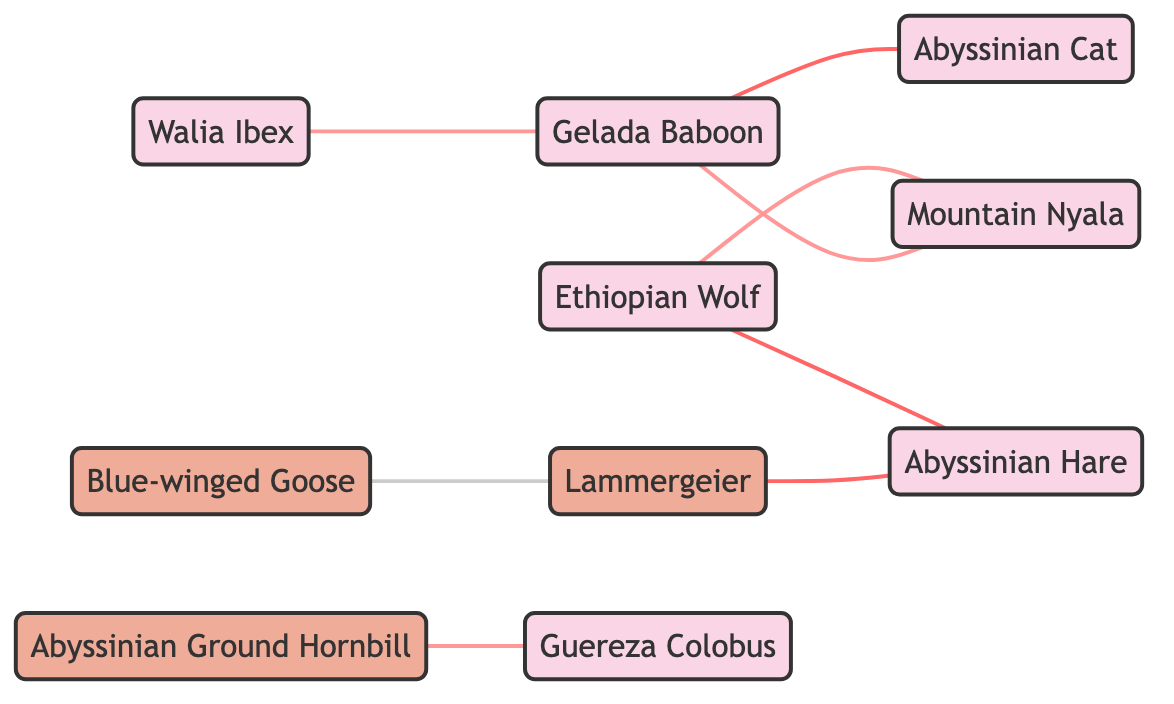What's the total number of nodes in the graph? The nodes represent different wildlife species. By counting them, we find there are 10 nodes in total listed: Walia Ibex, Gelada Baboon, Ethiopian Wolf, Abyssinian Cat, Mountain Nyala, Blue-winged Goose, Lammergeier, Abyssinian Ground Hornbill, Guereza Colobus, and Abyssinian Hare.
Answer: 10 Which species is involved in competition with the Walia Ibex? The relationship indicates that the Walia Ibex is in competition with the Gelada Baboon according to the edge connecting them. By examining the interaction edges, it is confirmed that they are competitors.
Answer: Gelada Baboon How many species are categorized as birds in the diagram? There are three species identified as birds in the list of nodes: Blue-winged Goose, Lammergeier, and Abyssinian Ground Hornbill. A count confirms that there are indeed three bird species.
Answer: 3 What type of interaction occurs between the Gelada Baboon and the Abyssinian Cat? The edge connecting the Gelada Baboon to the Abyssinian Cat indicates a predation interaction. By looking closely at this connection, the interaction type is identified as predation.
Answer: predation Which mammal species competes with the Ethiopian Wolf? According to the edges, the Ethiopian Wolf competes with the Mountain Nyala. This relationship is explicitly described as competition in the diagram.
Answer: Mountain Nyala How many edges indicate predation relationships in the diagram? By reviewing the edges in the graph, we find that there are four predation interactions: Gelada Baboon with Abyssinian Cat, Ethiopian Wolf with Abyssinian Hare, Lammergeier with Abyssinian Hare, and Gelada Baboon with Mountain Nyala. After counting the relevant edges, we confirm there are three predation edges.
Answer: 3 Which species avoids interaction with the Lammergeier? The Blue-winged Goose is shown to avoid interaction with the Lammergeier, as indicated by the avoidance interaction described in their connecting edge.
Answer: Blue-winged Goose What is the main interaction type between the Abyssinian Ground Hornbill and the Guereza Colobus? The edge between the Abyssinian Ground Hornbill and Guereza Colobus indicates competition. Upon examining the interactions, it is clear that competition is their primary relationship.
Answer: competition 